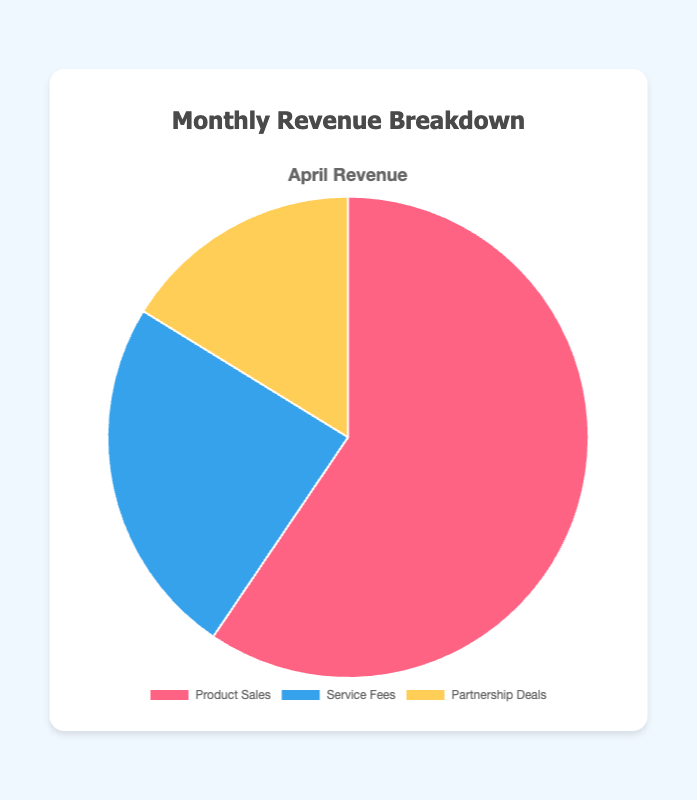What percentage of the total revenue does Product Sales represent in April? The total revenue for April is calculated by summing up Product Sales, Service Fees, and Partnership Deals. Therefore, the total revenue is 22000 + 9000 + 6000 = 37000. The percentage for Product Sales is (22000 / 37000) * 100 ≈ 59.46%.
Answer: 59.46% How does the revenue from Service Fees compare to Partnership Deals in April? In April, the revenue from Service Fees is 9000, and from Partnership Deals is 6000. To compare, Service Fees are larger than Partnership Deals.
Answer: Service Fees are larger than Partnership Deals Which revenue source has the smallest share in April? By examining the pie chart, it is evident that Partnership Deals have the smallest share among the three revenue sources in April.
Answer: Partnership Deals What is the difference in revenue between Product Sales and Service Fees in April? The revenue from Product Sales is 22000, while the revenue from Service Fees is 9000. The difference is 22000 - 9000 = 13000.
Answer: 13000 If the total monthly revenue is 37000, what fraction of it comes from Partnership Deals? The revenue from Partnership Deals is 6000. The fraction of total revenue from Partnership Deals is 6000 / 37000 = 0.1622.
Answer: 0.1622 What is the combined revenue from Service Fees and Partnership Deals in April? The revenue from Service Fees is 9000 and from Partnership Deals is 6000. Combined, the revenue is 9000 + 6000 = 15000.
Answer: 15000 What is the average revenue per category (Product Sales, Service Fees, Partnership Deals) in April? The total revenue is 37000 for April, distributed among three categories. The average revenue per category is 37000 / 3 ≈ 12333.33.
Answer: 12333.33 Which category has the highest revenue in April? By looking at the pie chart, it is clear that Product Sales have the highest revenue in April.
Answer: Product Sales 